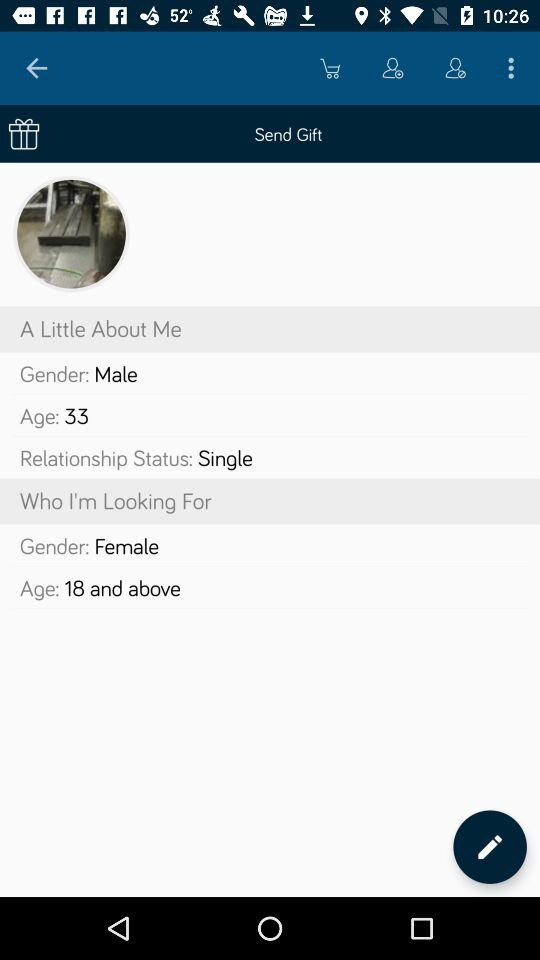What gender is the person looking for? The person is looking for the female gender. 